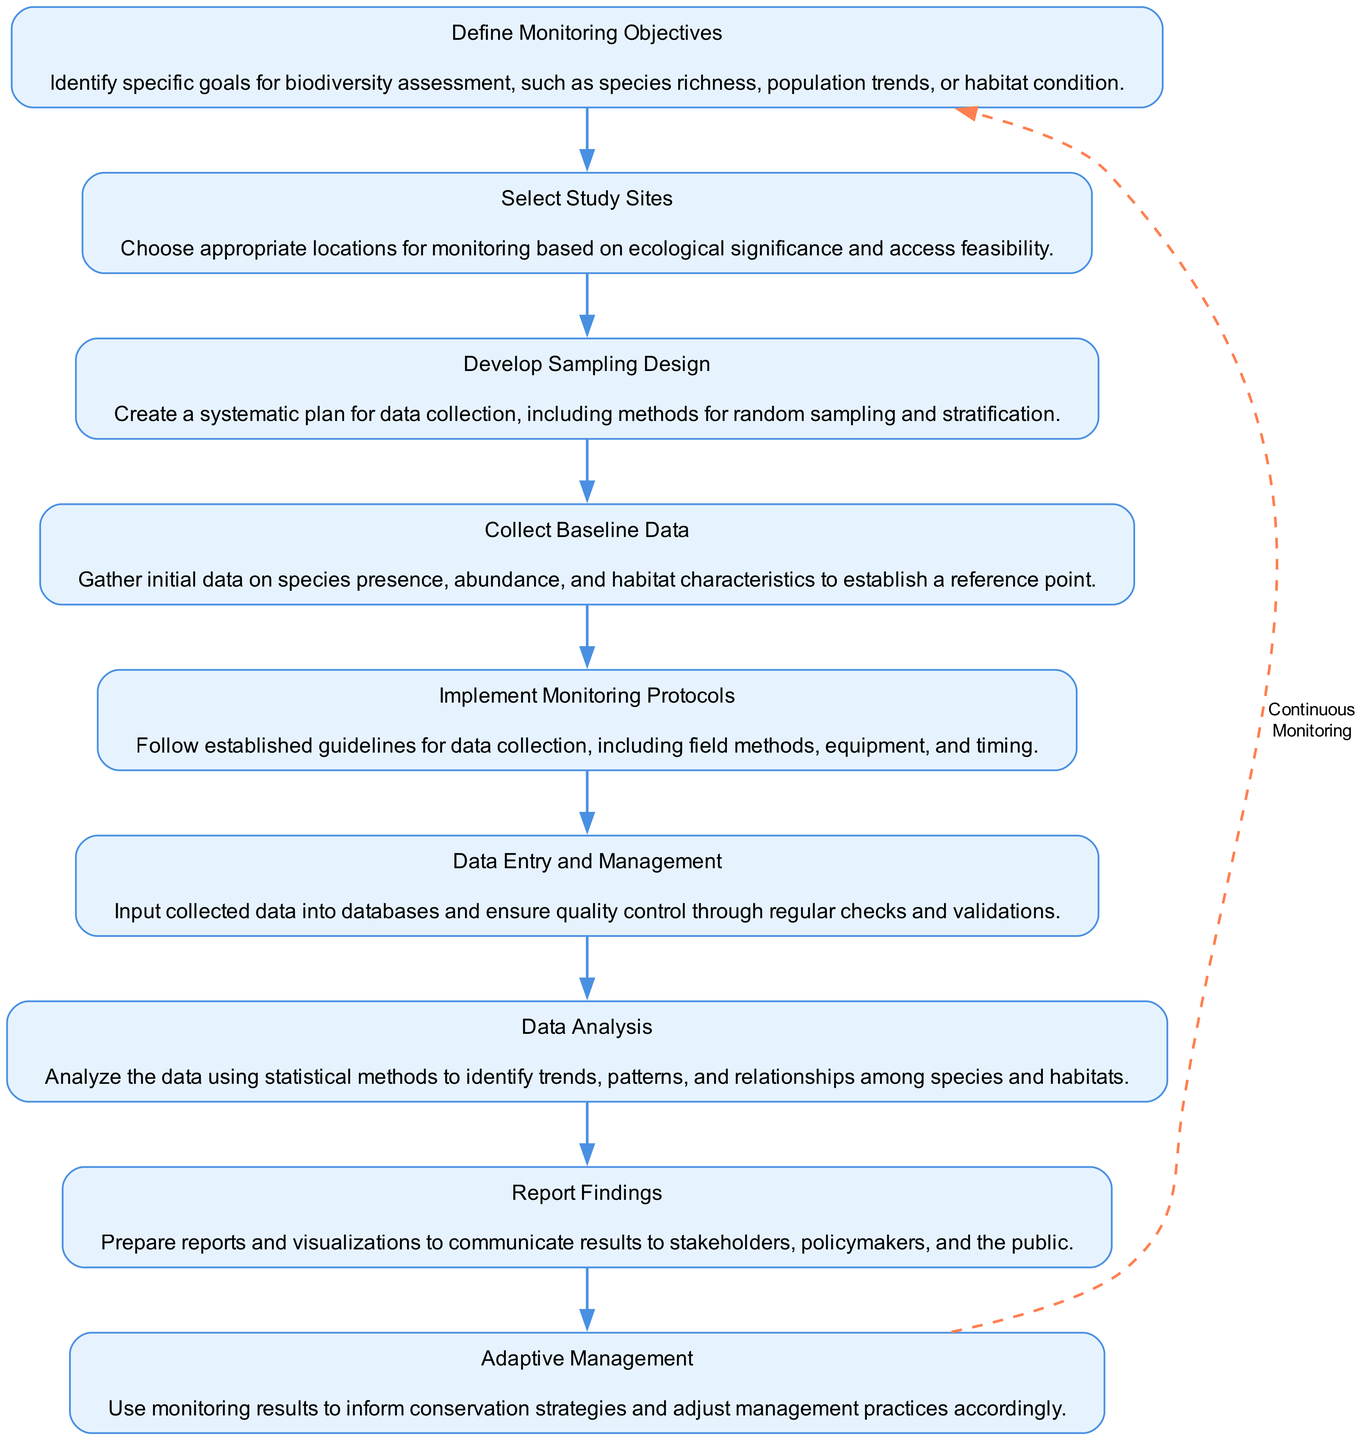What is the first step in the flow chart? The first step in the flow chart is "Define Monitoring Objectives," which is indicated as the topmost node in the flow, initiating the sequence of actions.
Answer: Define Monitoring Objectives How many nodes are in the diagram? The diagram shows a total of 9 distinct nodes, representing each key step in the biodiversity monitoring program.
Answer: 9 What is the last node before "Adaptive Management"? The last node before "Adaptive Management" is "Report Findings," which directly precedes the adaptive management process.
Answer: Report Findings Which node involves inputting data into databases? The node that involves inputting data into databases is "Data Entry and Management," which is specifically focused on organizing and overseeing data collection.
Answer: Data Entry and Management What is the relationship between "Collect Baseline Data" and "Implement Monitoring Protocols"? "Collect Baseline Data" is followed by "Implement Monitoring Protocols," indicating that baseline data collection occurs prior to the execution of monitoring protocols in the workflow.
Answer: Sequential relationship What is the purpose of "Data Analysis"? The purpose of "Data Analysis" is to analyze the collected data using statistical methods to determine trends and relationships in the data regarding species and habitats.
Answer: Identify trends and relationships How does the flow chart suggest managing conservation strategies? The flow chart suggests managing conservation strategies through "Adaptive Management," which utilizes results from monitoring to inform and adjust management practices as necessary.
Answer: Use monitoring results Which node has a dashed edge leading back to the first node? The dashed edge leading back to the first node is connected to "Report Findings," indicating that findings are used to inform continuous monitoring efforts.
Answer: Report Findings How many edges connect the nodes sequentially? There are 8 edges connecting the nodes sequentially, as each node (except the first) is linked directly to the preceding node.
Answer: 8 